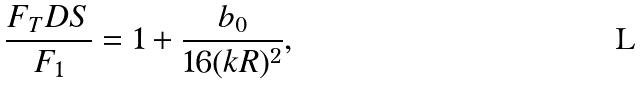Convert formula to latex. <formula><loc_0><loc_0><loc_500><loc_500>\frac { F _ { T } D S } { F _ { 1 } } = 1 + \frac { b _ { 0 } } { 1 6 ( k R ) ^ { 2 } } ,</formula> 